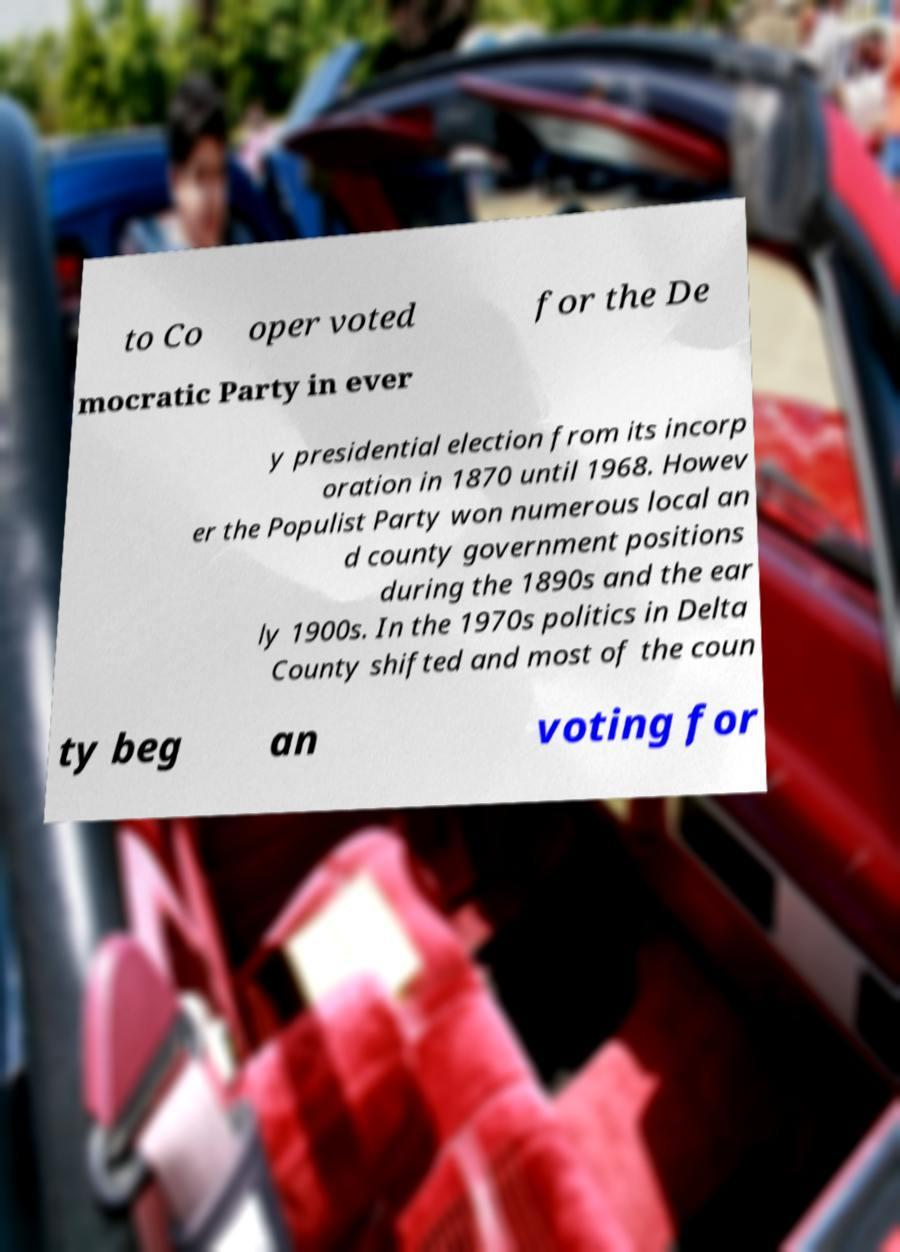Can you read and provide the text displayed in the image?This photo seems to have some interesting text. Can you extract and type it out for me? to Co oper voted for the De mocratic Party in ever y presidential election from its incorp oration in 1870 until 1968. Howev er the Populist Party won numerous local an d county government positions during the 1890s and the ear ly 1900s. In the 1970s politics in Delta County shifted and most of the coun ty beg an voting for 